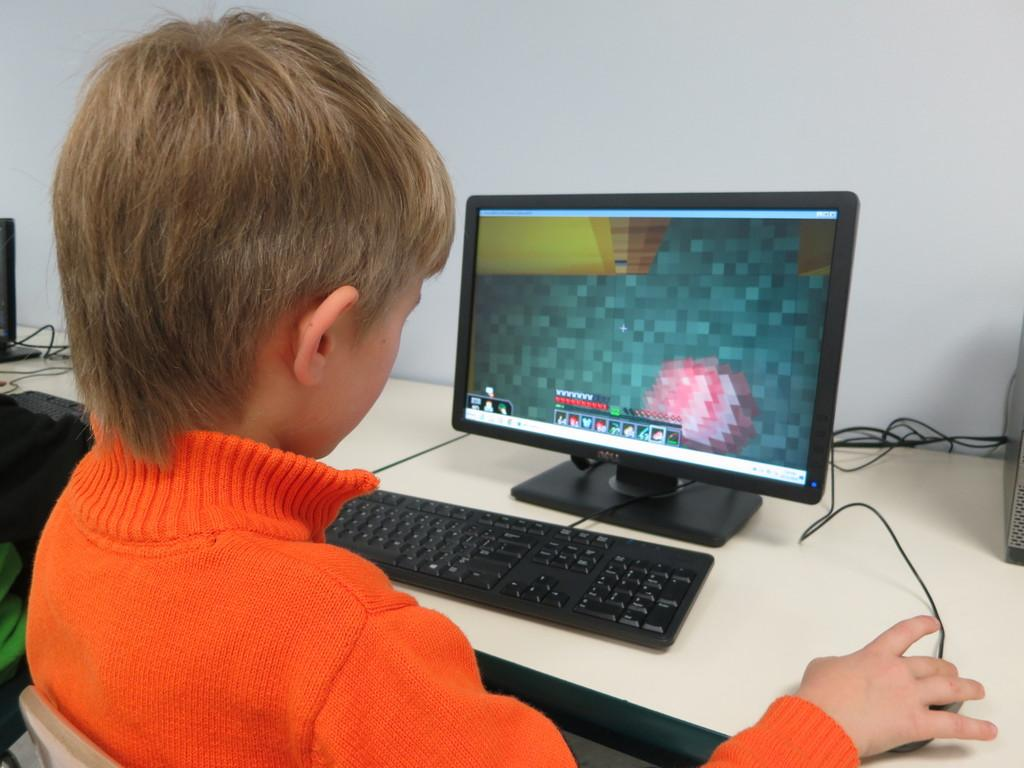<image>
Offer a succinct explanation of the picture presented. a boy uses a computer with a start logo on it 